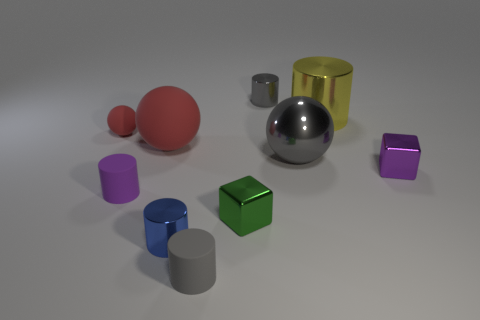Subtract all yellow cylinders. How many cylinders are left? 4 Subtract all gray metallic cylinders. How many cylinders are left? 4 Subtract all brown blocks. Subtract all gray balls. How many blocks are left? 2 Subtract all balls. How many objects are left? 7 Subtract all green shiny blocks. Subtract all small cylinders. How many objects are left? 5 Add 2 large yellow objects. How many large yellow objects are left? 3 Add 1 metal cylinders. How many metal cylinders exist? 4 Subtract 0 green spheres. How many objects are left? 10 